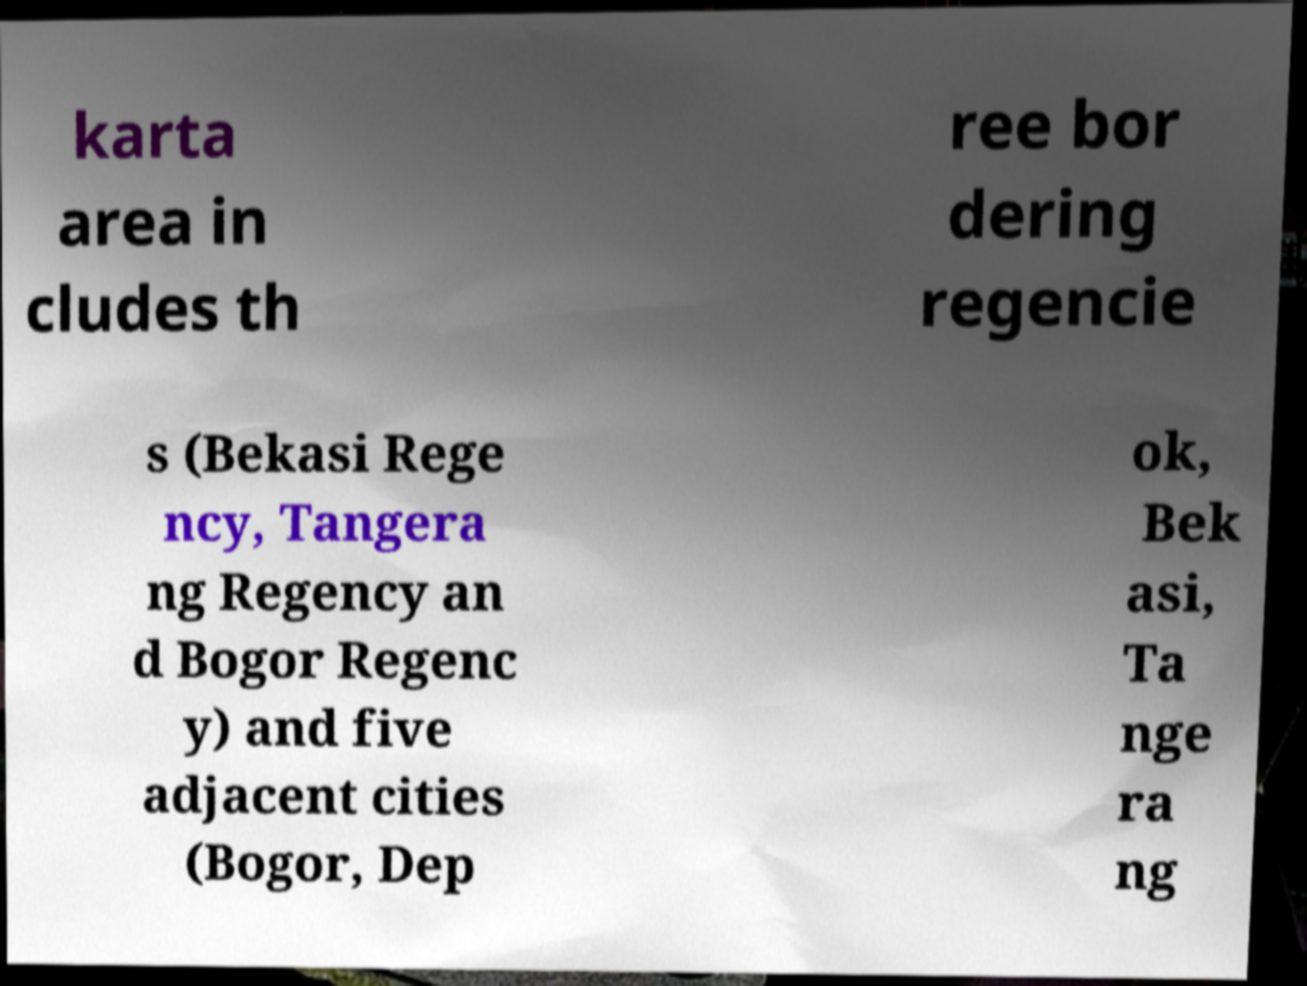Can you accurately transcribe the text from the provided image for me? karta area in cludes th ree bor dering regencie s (Bekasi Rege ncy, Tangera ng Regency an d Bogor Regenc y) and five adjacent cities (Bogor, Dep ok, Bek asi, Ta nge ra ng 